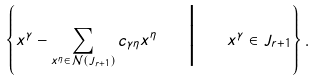<formula> <loc_0><loc_0><loc_500><loc_500>\left \{ x ^ { \gamma } - \sum _ { x ^ { \eta } \in \mathcal { N } ( J _ { r + 1 } ) } c _ { \gamma \eta } x ^ { \eta } \quad \Big | \quad x ^ { \gamma } \in J _ { r + 1 } \right \} .</formula> 